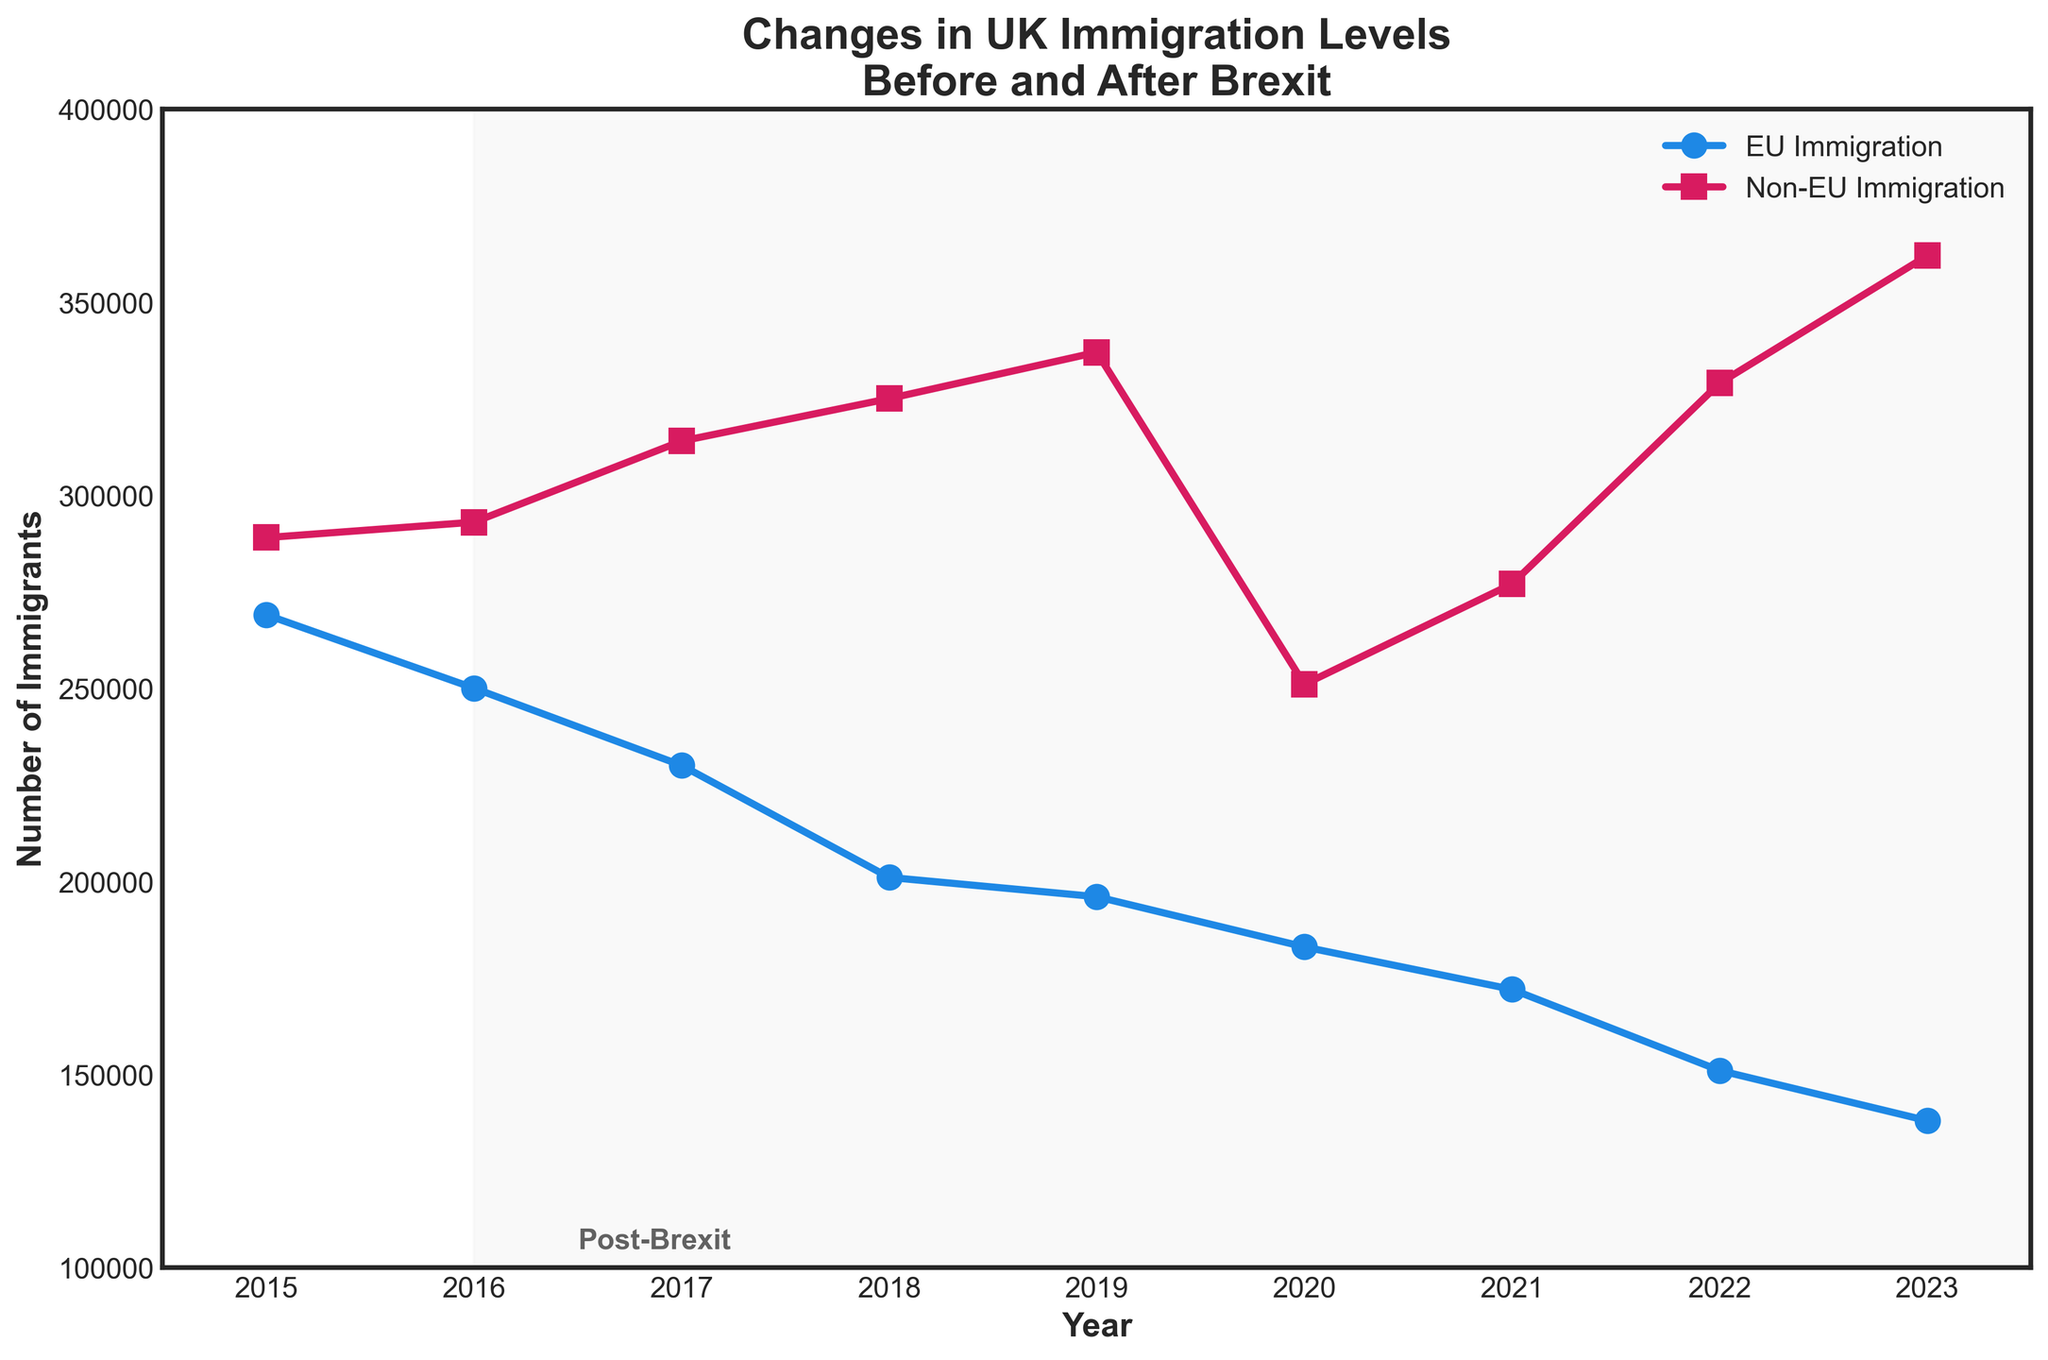How did EU immigration levels change from 2015 to 2023? EU immigration levels decreased from 269,000 in 2015 to 138,000 in 2023. This can be seen as a downward trend on the line representing EU immigration in the figure.
Answer: They decreased Which year had the highest level of non-EU immigration? The highest level of non-EU immigration is represented by the peak of the non-EU immigration line in the figure, occurring in 2023 with 362,000 immigrants.
Answer: 2023 By how much did EU immigration decrease between 2015 and 2020? EU immigration decreased from 269,000 in 2015 to 183,000 in 2020. The difference is calculated as 269,000 - 183,000.
Answer: 86,000 In 2016, which was higher: EU immigration or non-EU immigration? In 2016, EU immigration was 250,000 and non-EU immigration was 293,000. The figure shows that non-EU immigration was higher than EU immigration that year.
Answer: Non-EU immigration Which immigration type showed a more significant decline post-Brexit (after 2016)? Post-Brexit (2016-2023), the figure shows a more significant decline in EU immigration as compared to non-EU immigration. EU immigration decreased from 250,000 in 2016 to 138,000 in 2023, whereas non-EU immigration increased from 293,000 in 2016 to 362,000 in 2023.
Answer: EU immigration What is the average level of EU immigration from 2015 to 2023? The average is calculated by summing the EU immigration levels from 2015 to 2023 (269,000 + 250,000 + 230,000 + 201,000 + 196,000 + 183,000 + 172,000 + 151,000 + 138,000) and dividing by the number of years (9). The sum is 1,790,000, so the average is 1,790,000 / 9.
Answer: 198,889 How much did non-EU immigration increase from 2016 to 2023? Non-EU immigration increased from 293,000 in 2016 to 362,000 in 2023. The increase is calculated as 362,000 - 293,000.
Answer: 69,000 Which color represents EU immigration in the figure, and what is its general trend? The color representing EU immigration in the figure is blue, and the general trend is a downward decline from 2015 to 2023.
Answer: Blue, downward How does the trend of non-EU immigration compare to EU immigration post-Brexit? Post-Brexit, non-EU immigration shows an overall increasing trend while EU immigration shows a decreasing trend. This is evident by visually comparing the slopes of the lines for each immigration type after 2016.
Answer: Non-EU increasing, EU decreasing 